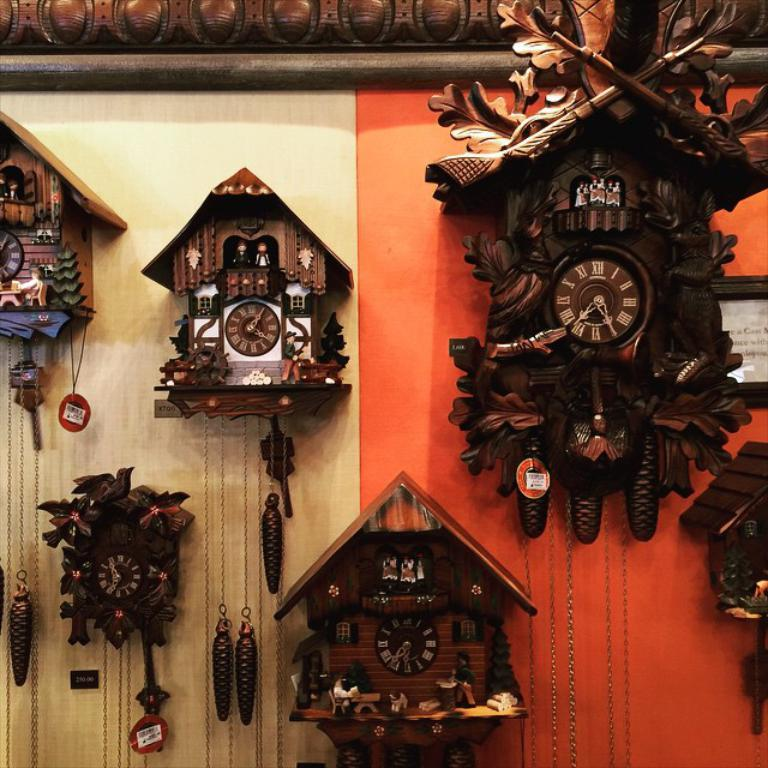<image>
Give a short and clear explanation of the subsequent image. Several cuckoo clocks on a wall, set to 4:05, 7:25, 6:37, and 6:54. 